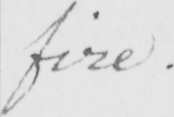What is written in this line of handwriting? fire . 